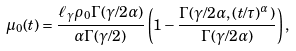<formula> <loc_0><loc_0><loc_500><loc_500>\mu _ { 0 } ( t ) = \frac { \ell _ { \gamma } \rho _ { 0 } \Gamma ( \gamma / 2 \alpha ) } { \alpha \Gamma ( \gamma / 2 ) } \left ( 1 - \frac { \Gamma ( \gamma / 2 \alpha , ( t / \tau ) ^ { \alpha } ) } { \Gamma ( \gamma / 2 \alpha ) } \right ) ,</formula> 